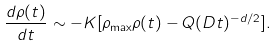Convert formula to latex. <formula><loc_0><loc_0><loc_500><loc_500>\frac { d \rho ( t ) } { d t } \sim - K [ \rho _ { \max } \rho ( t ) - Q ( D t ) ^ { - d / 2 } ] .</formula> 